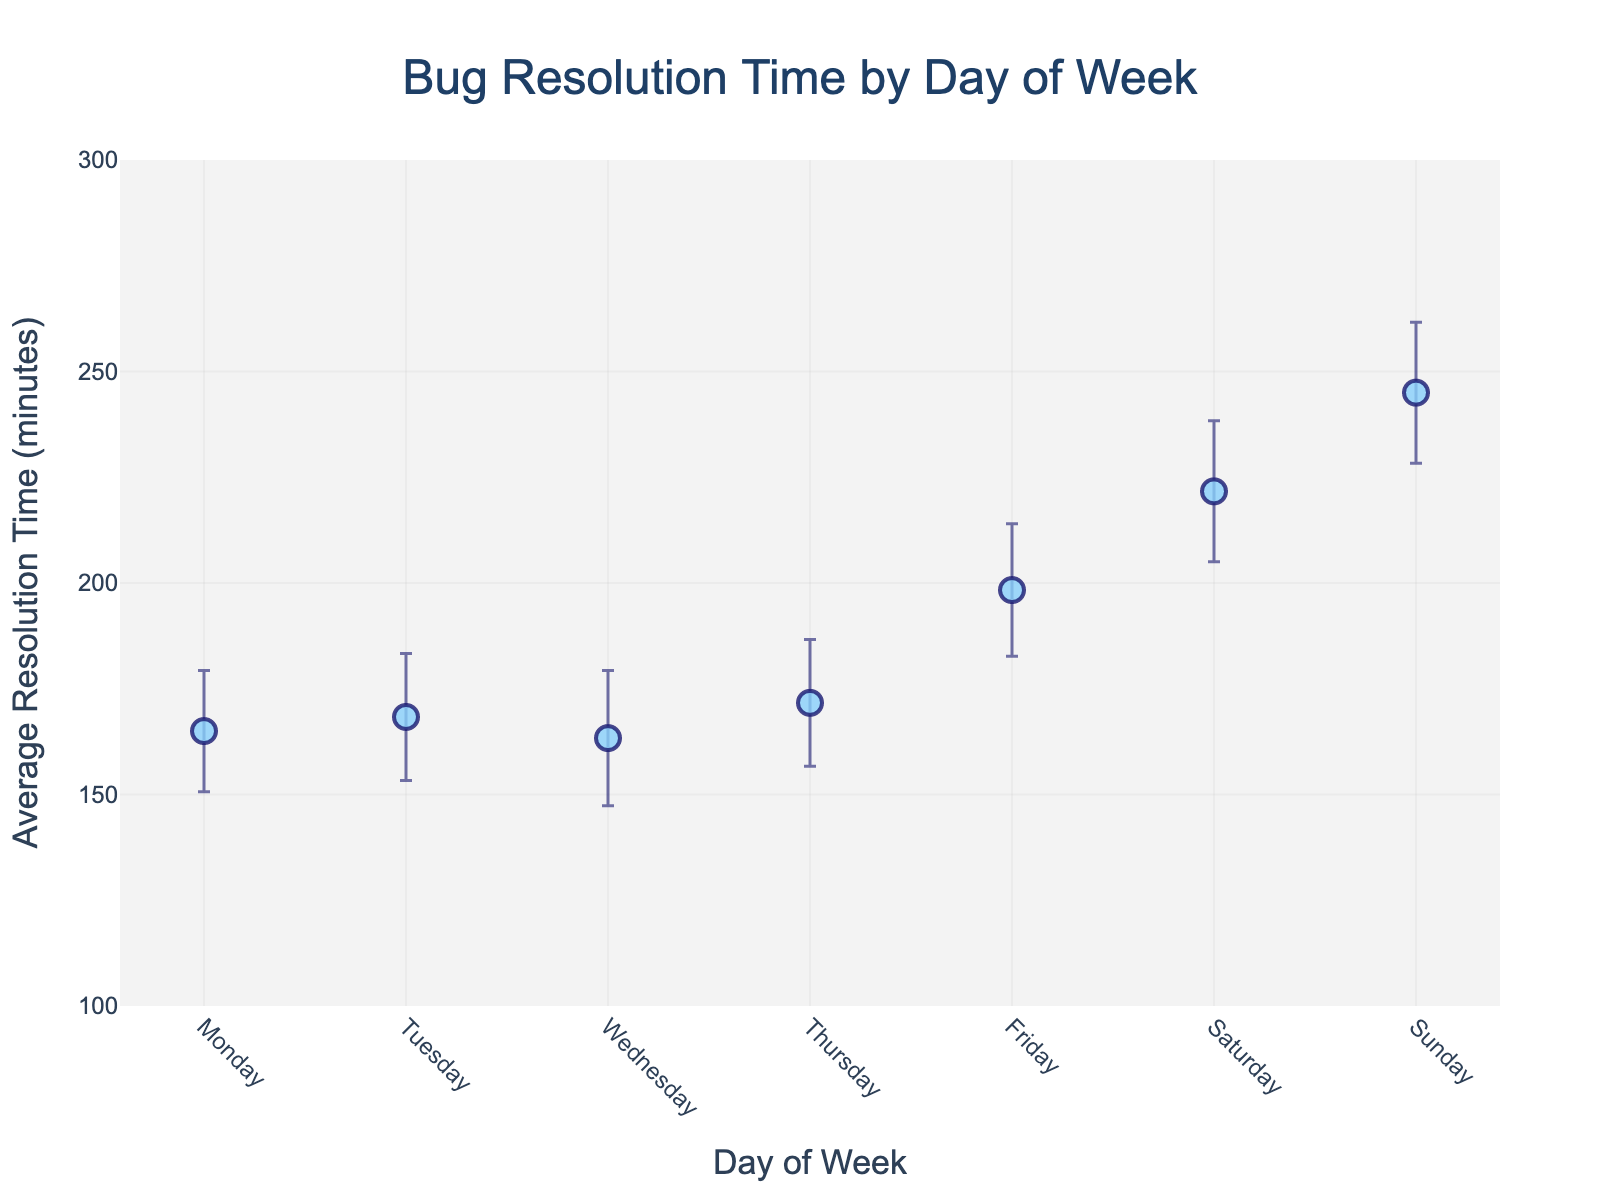What is the title of the figure? The title of the figure is displayed at the top center, and it is clearly labeled as "Bug Resolution Time by Day of Week".
Answer: Bug Resolution Time by Day of Week Which day has the highest average bug resolution time? Look at the markers and find the one with the highest y-value. The marker for Sunday is the highest.
Answer: Sunday What is the average bug resolution time on Monday? Find the marker corresponding to Monday and note its y-value. The average bug resolution time on Monday is 165 minutes.
Answer: 165 minutes Are there any days where the average bug resolution time is below 150 minutes? Look at the markers and find those with y-values below 150. Only Wednesday has an average below 150 minutes.
Answer: Wednesday What is the confidence interval range for Friday? Check the error bars for Friday. The lower bound is 182 and the upper bound is 214, so the range is from 182 to 214 minutes.
Answer: 182 to 214 minutes How does Saturday's average bug resolution time compare to Tuesday's? Compare the y-values for Saturday and Tuesday. Saturday's average (221 minutes) is higher than Tuesday's (168 minutes).
Answer: Saturday's is higher Which day has the largest confidence interval range? Look at the length of the error bars for each day. Sunday has the longest error bars, indicating the largest confidence interval range.
Answer: Sunday What is the difference in the average bug resolution time between Monday and Thursday? Find the y-values for Monday and Thursday and subtract them. Monday's average is 165 minutes, and Thursday's average is 172 minutes. The difference is 172 - 165 = 7 minutes.
Answer: 7 minutes What is the longest average bug resolution time? Identify the highest point on the y-axis. Sunday has the longest average bug resolution time at 245 minutes.
Answer: 245 minutes What is the shortest average bug resolution time? Identify the lowest point on the y-axis. Wednesday has the shortest average bug resolution time at 145 minutes.
Answer: 145 minutes 